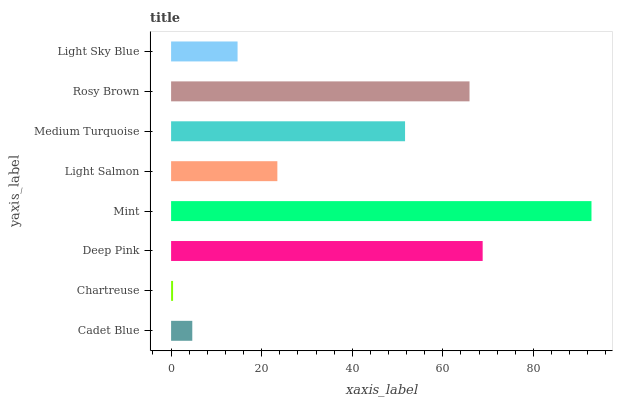Is Chartreuse the minimum?
Answer yes or no. Yes. Is Mint the maximum?
Answer yes or no. Yes. Is Deep Pink the minimum?
Answer yes or no. No. Is Deep Pink the maximum?
Answer yes or no. No. Is Deep Pink greater than Chartreuse?
Answer yes or no. Yes. Is Chartreuse less than Deep Pink?
Answer yes or no. Yes. Is Chartreuse greater than Deep Pink?
Answer yes or no. No. Is Deep Pink less than Chartreuse?
Answer yes or no. No. Is Medium Turquoise the high median?
Answer yes or no. Yes. Is Light Salmon the low median?
Answer yes or no. Yes. Is Rosy Brown the high median?
Answer yes or no. No. Is Mint the low median?
Answer yes or no. No. 